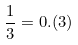<formula> <loc_0><loc_0><loc_500><loc_500>\frac { 1 } { 3 } = 0 . ( 3 )</formula> 